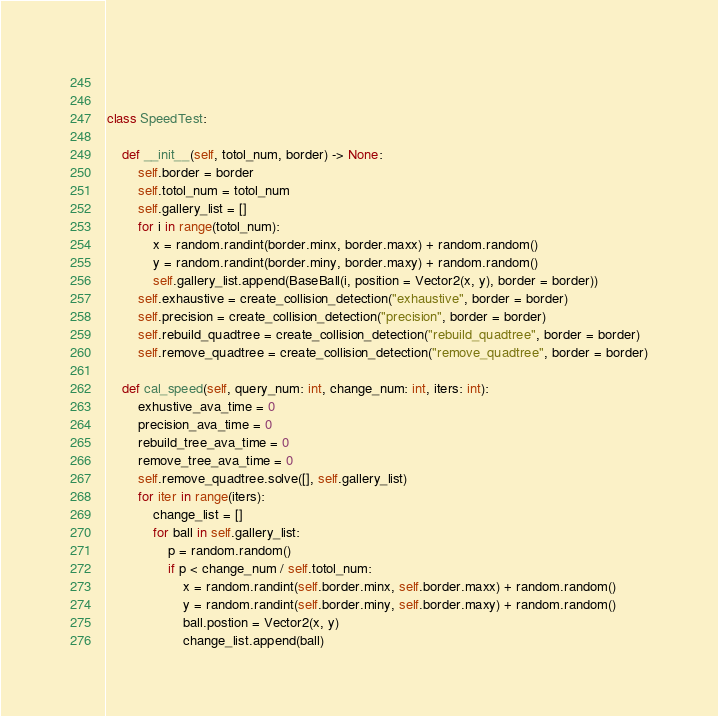Convert code to text. <code><loc_0><loc_0><loc_500><loc_500><_Python_>        

class SpeedTest:

    def __init__(self, totol_num, border) -> None:
        self.border = border
        self.totol_num = totol_num
        self.gallery_list = []
        for i in range(totol_num):
            x = random.randint(border.minx, border.maxx) + random.random()
            y = random.randint(border.miny, border.maxy) + random.random()
            self.gallery_list.append(BaseBall(i, position = Vector2(x, y), border = border))
        self.exhaustive = create_collision_detection("exhaustive", border = border)
        self.precision = create_collision_detection("precision", border = border)
        self.rebuild_quadtree = create_collision_detection("rebuild_quadtree", border = border)
        self.remove_quadtree = create_collision_detection("remove_quadtree", border = border)

    def cal_speed(self, query_num: int, change_num: int, iters: int):
        exhustive_ava_time = 0
        precision_ava_time = 0
        rebuild_tree_ava_time = 0
        remove_tree_ava_time = 0
        self.remove_quadtree.solve([], self.gallery_list)
        for iter in range(iters):
            change_list = []
            for ball in self.gallery_list:
                p = random.random()
                if p < change_num / self.totol_num:
                    x = random.randint(self.border.minx, self.border.maxx) + random.random()
                    y = random.randint(self.border.miny, self.border.maxy) + random.random()
                    ball.postion = Vector2(x, y)
                    change_list.append(ball)</code> 